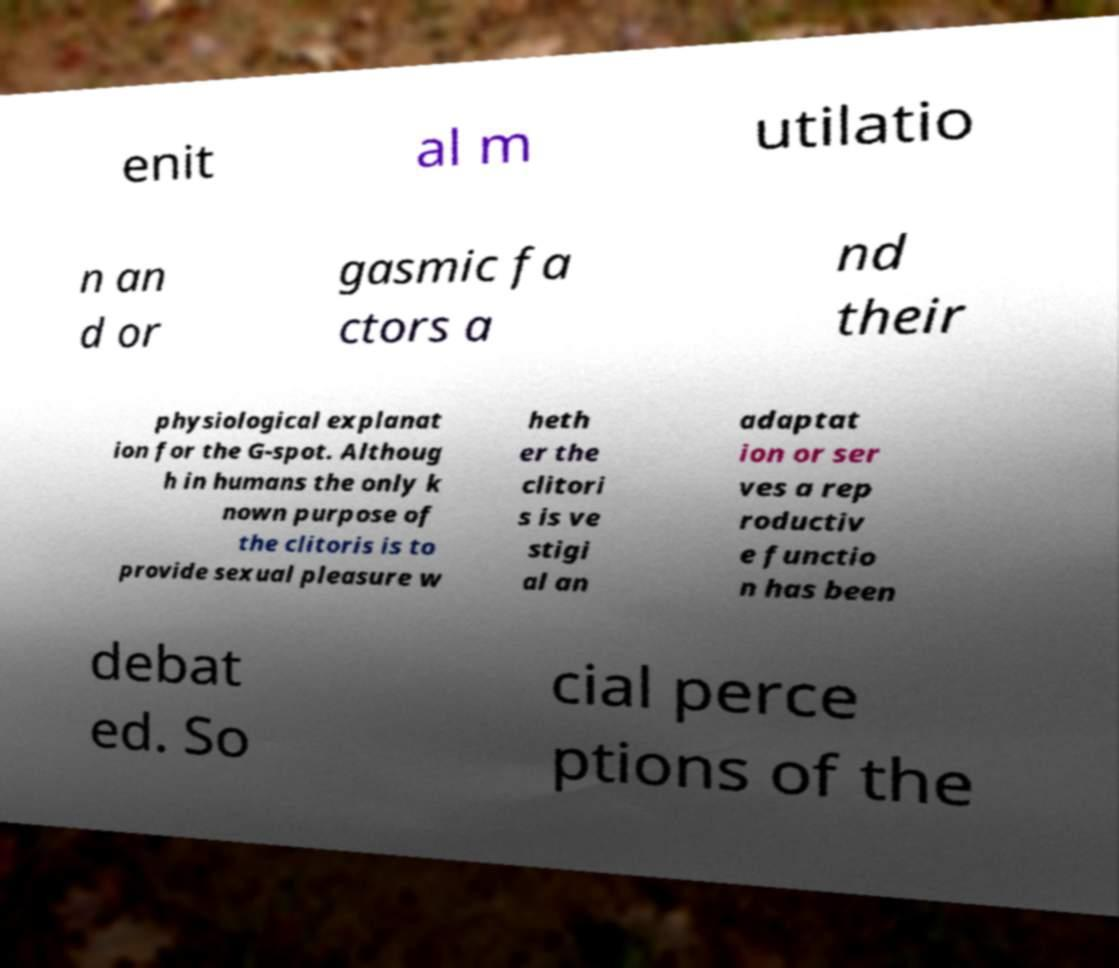There's text embedded in this image that I need extracted. Can you transcribe it verbatim? enit al m utilatio n an d or gasmic fa ctors a nd their physiological explanat ion for the G-spot. Althoug h in humans the only k nown purpose of the clitoris is to provide sexual pleasure w heth er the clitori s is ve stigi al an adaptat ion or ser ves a rep roductiv e functio n has been debat ed. So cial perce ptions of the 